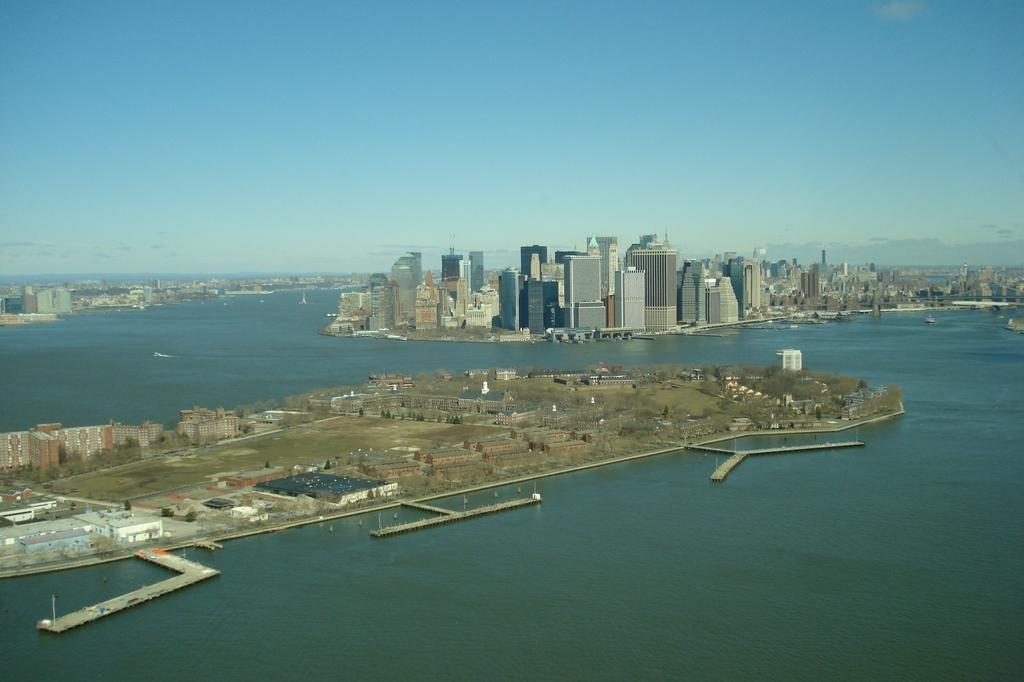What is the primary element visible in the image? There is water in the image. What else can be seen in the image besides water? There is ground, trees, bridges, buildings, and the sky visible in the image. Can you describe the sky in the image? The sky is visible in the background of the image, and there are clouds present. What type of structures can be seen in the image? There are bridges and buildings visible in the image. How does the water get drained from the image? The water does not get drained from the image; it is a static element in the scene. What type of paste is used to create the clouds in the image? There is no paste used to create the clouds in the image; they are a natural atmospheric phenomenon. 